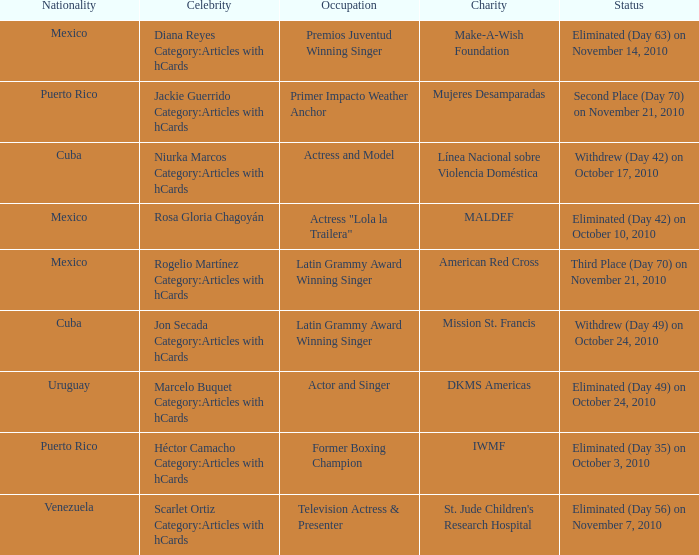What is the charity for the celebrity with an occupation title of actor and singer? DKMS Americas. 